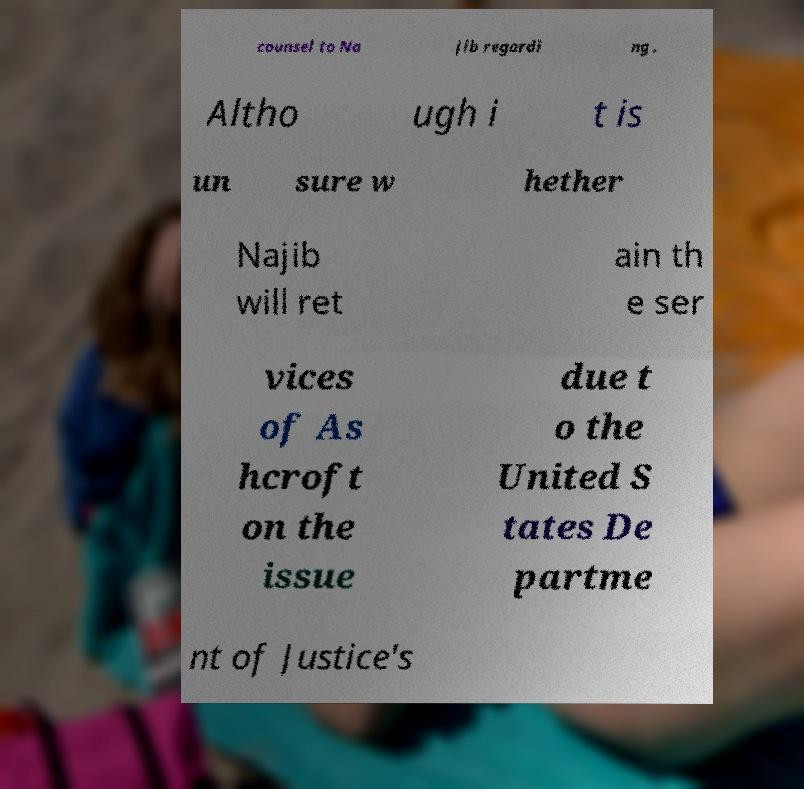There's text embedded in this image that I need extracted. Can you transcribe it verbatim? counsel to Na jib regardi ng . Altho ugh i t is un sure w hether Najib will ret ain th e ser vices of As hcroft on the issue due t o the United S tates De partme nt of Justice's 